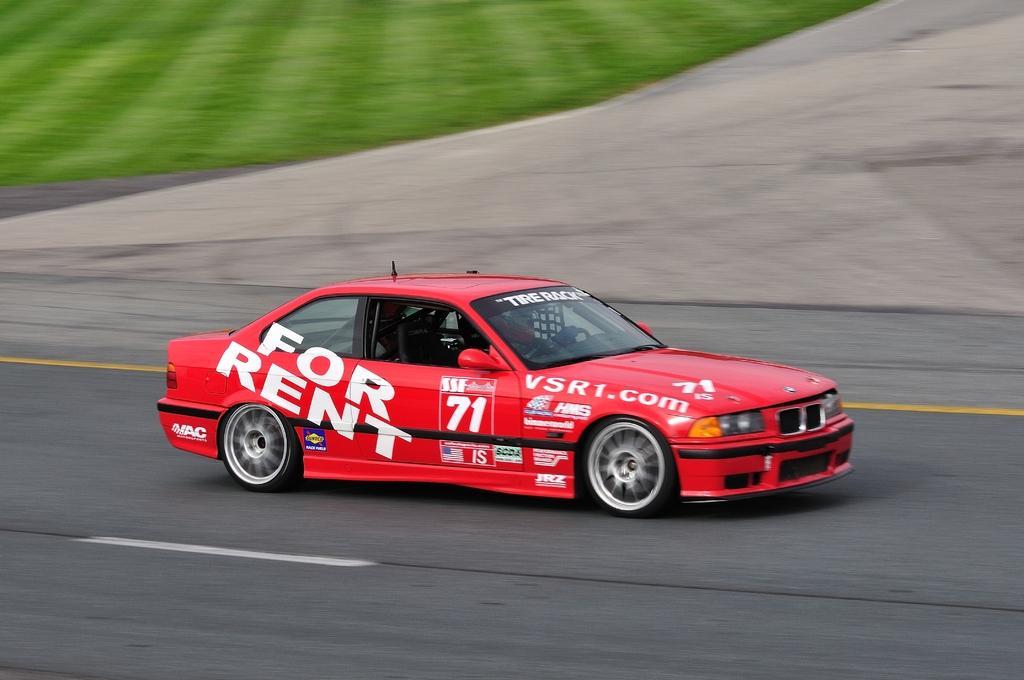Describe this image in one or two sentences. In this image in the center there is one car, at the bottom there is road and in the background there is grass. 